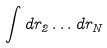<formula> <loc_0><loc_0><loc_500><loc_500>\int d r _ { 2 } \dots d r _ { N }</formula> 